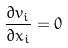Convert formula to latex. <formula><loc_0><loc_0><loc_500><loc_500>\frac { \partial v _ { i } } { \partial x _ { i } } = 0</formula> 